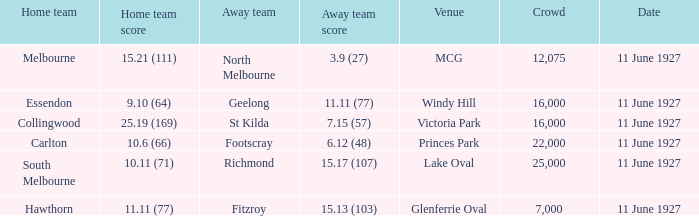How many individuals are in the combined crowds at glenferrie oval? 7000.0. 